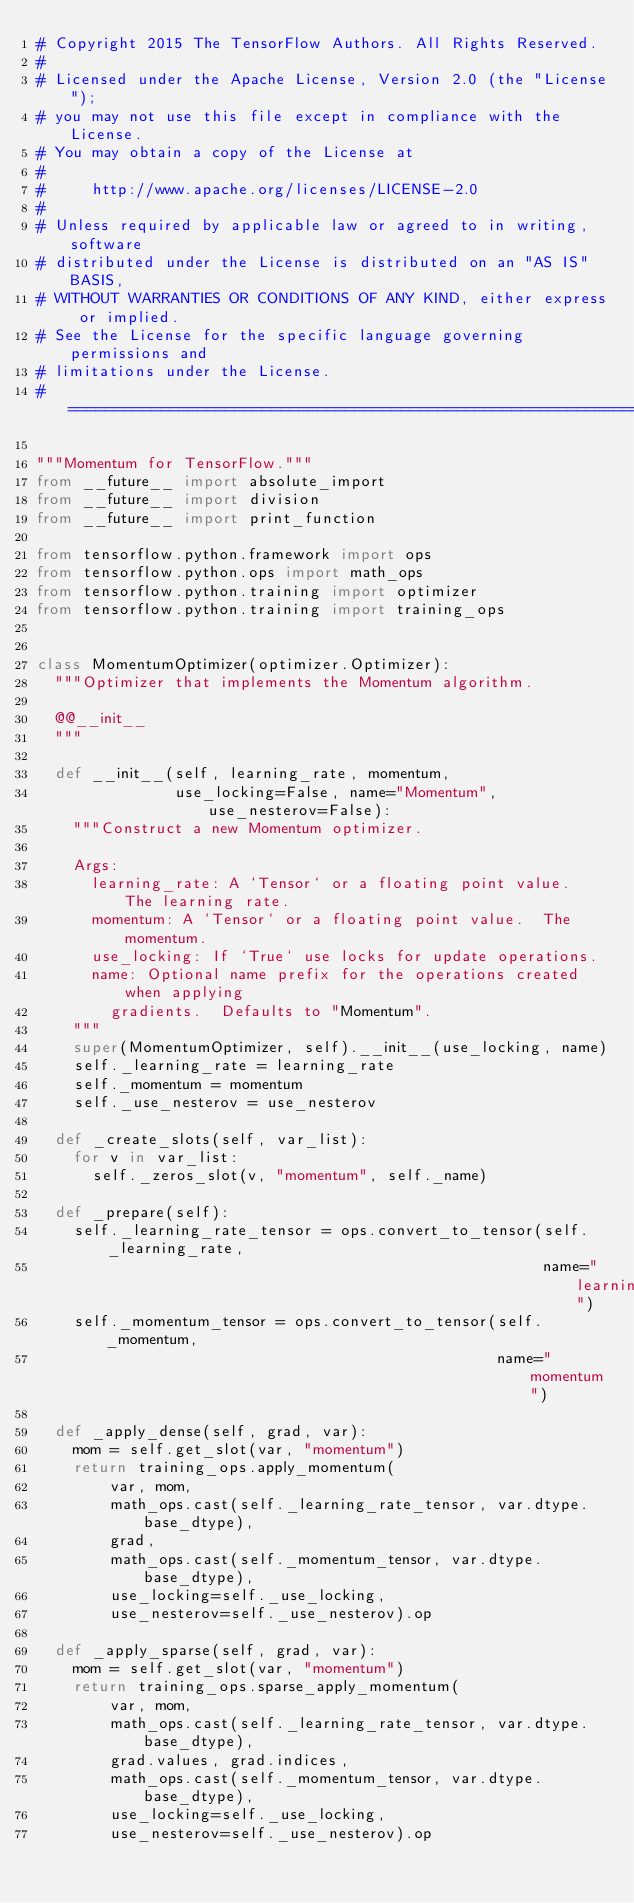Convert code to text. <code><loc_0><loc_0><loc_500><loc_500><_Python_># Copyright 2015 The TensorFlow Authors. All Rights Reserved.
#
# Licensed under the Apache License, Version 2.0 (the "License");
# you may not use this file except in compliance with the License.
# You may obtain a copy of the License at
#
#     http://www.apache.org/licenses/LICENSE-2.0
#
# Unless required by applicable law or agreed to in writing, software
# distributed under the License is distributed on an "AS IS" BASIS,
# WITHOUT WARRANTIES OR CONDITIONS OF ANY KIND, either express or implied.
# See the License for the specific language governing permissions and
# limitations under the License.
# ==============================================================================

"""Momentum for TensorFlow."""
from __future__ import absolute_import
from __future__ import division
from __future__ import print_function

from tensorflow.python.framework import ops
from tensorflow.python.ops import math_ops
from tensorflow.python.training import optimizer
from tensorflow.python.training import training_ops


class MomentumOptimizer(optimizer.Optimizer):
  """Optimizer that implements the Momentum algorithm.

  @@__init__
  """

  def __init__(self, learning_rate, momentum,
               use_locking=False, name="Momentum", use_nesterov=False):
    """Construct a new Momentum optimizer.

    Args:
      learning_rate: A `Tensor` or a floating point value.  The learning rate.
      momentum: A `Tensor` or a floating point value.  The momentum.
      use_locking: If `True` use locks for update operations.
      name: Optional name prefix for the operations created when applying
        gradients.  Defaults to "Momentum".
    """
    super(MomentumOptimizer, self).__init__(use_locking, name)
    self._learning_rate = learning_rate
    self._momentum = momentum
    self._use_nesterov = use_nesterov

  def _create_slots(self, var_list):
    for v in var_list:
      self._zeros_slot(v, "momentum", self._name)

  def _prepare(self):
    self._learning_rate_tensor = ops.convert_to_tensor(self._learning_rate,
                                                       name="learning_rate")
    self._momentum_tensor = ops.convert_to_tensor(self._momentum,
                                                  name="momentum")

  def _apply_dense(self, grad, var):
    mom = self.get_slot(var, "momentum")
    return training_ops.apply_momentum(
        var, mom,
        math_ops.cast(self._learning_rate_tensor, var.dtype.base_dtype),
        grad,
        math_ops.cast(self._momentum_tensor, var.dtype.base_dtype),
        use_locking=self._use_locking,
        use_nesterov=self._use_nesterov).op

  def _apply_sparse(self, grad, var):
    mom = self.get_slot(var, "momentum")
    return training_ops.sparse_apply_momentum(
        var, mom,
        math_ops.cast(self._learning_rate_tensor, var.dtype.base_dtype),
        grad.values, grad.indices,
        math_ops.cast(self._momentum_tensor, var.dtype.base_dtype),
        use_locking=self._use_locking,
        use_nesterov=self._use_nesterov).op
</code> 